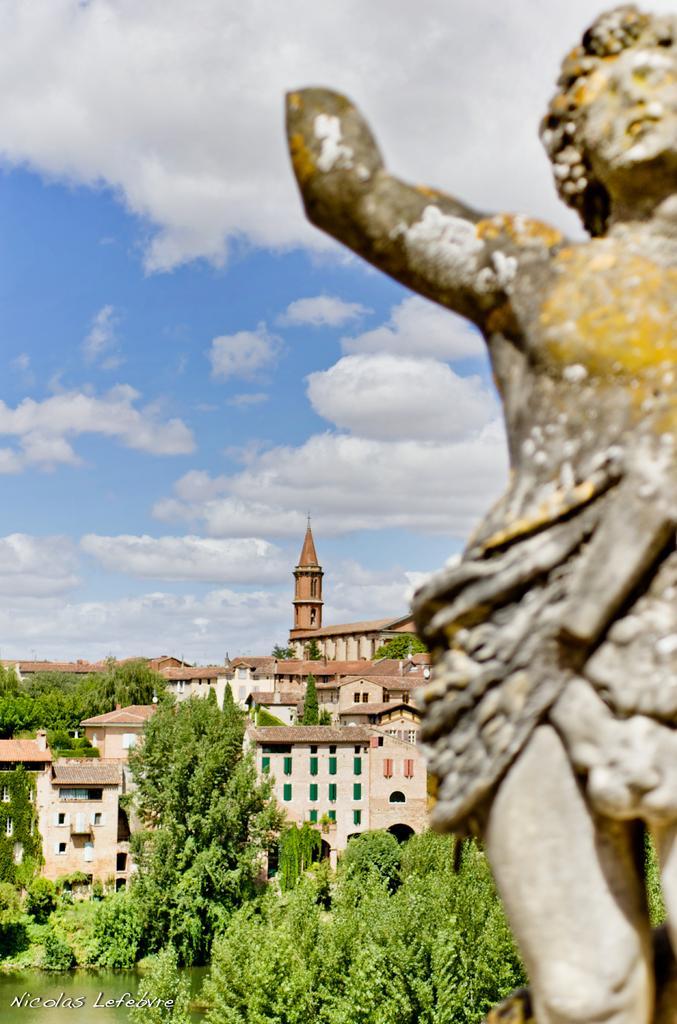Could you give a brief overview of what you see in this image? In this picture I can observe a statue on the right side. There are some buildings and trees in this picture. In the background there is a sky and there are some clouds in the sky. 